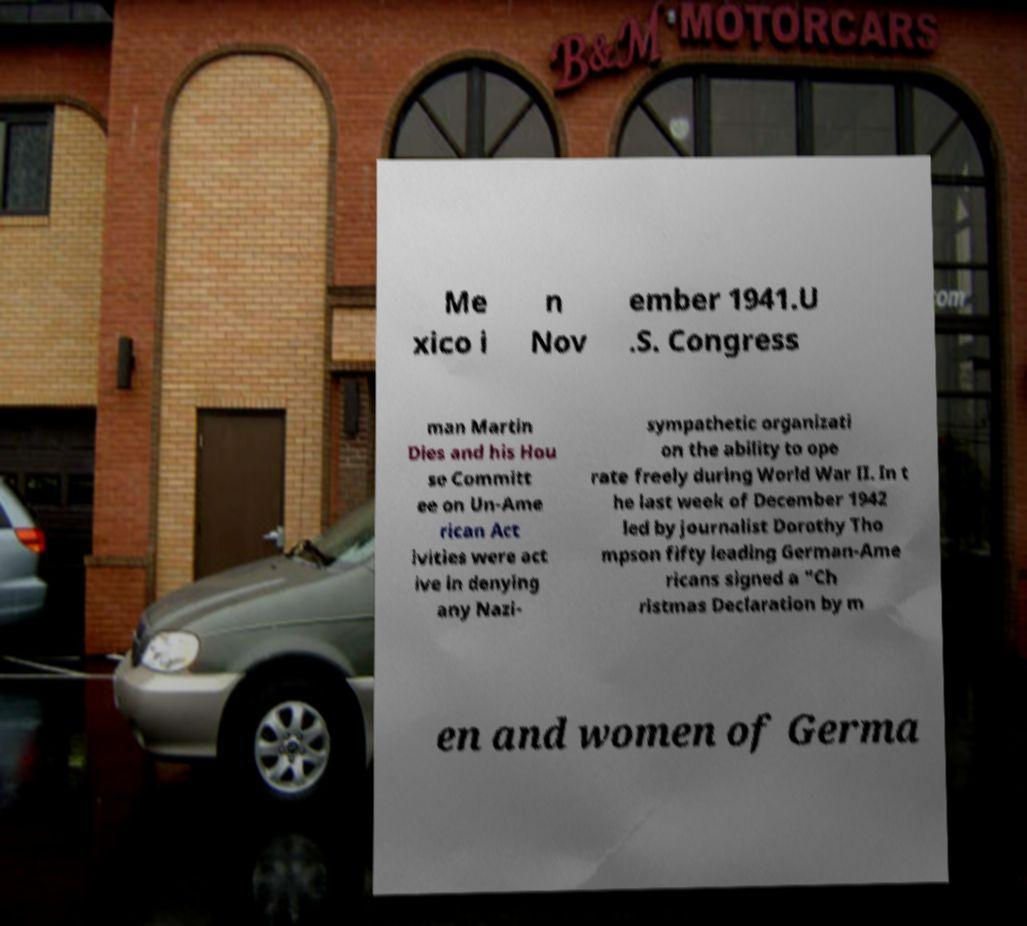Please identify and transcribe the text found in this image. Me xico i n Nov ember 1941.U .S. Congress man Martin Dies and his Hou se Committ ee on Un-Ame rican Act ivities were act ive in denying any Nazi- sympathetic organizati on the ability to ope rate freely during World War II. In t he last week of December 1942 led by journalist Dorothy Tho mpson fifty leading German-Ame ricans signed a "Ch ristmas Declaration by m en and women of Germa 